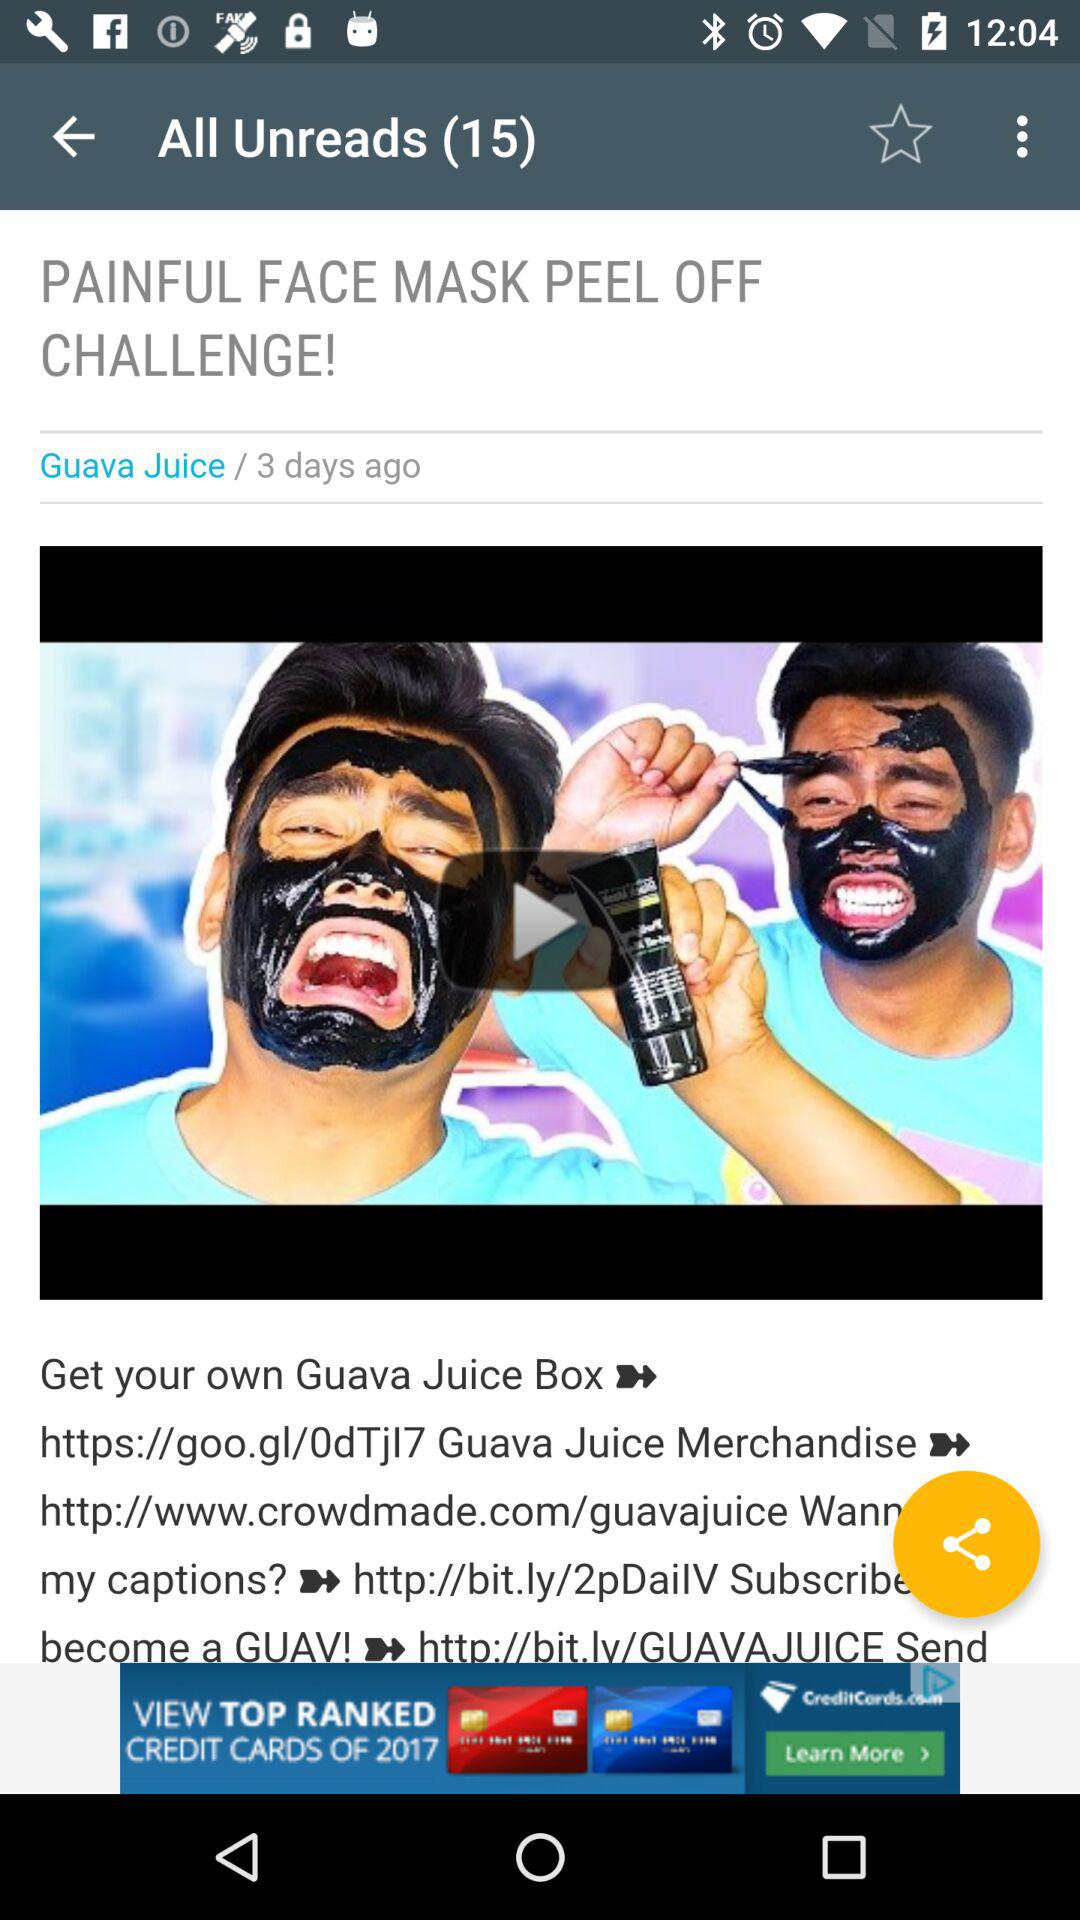What is the title of the video? The title of the video is "PAINFUL FACE MASK PEEL OFF CHALLENGE!". 